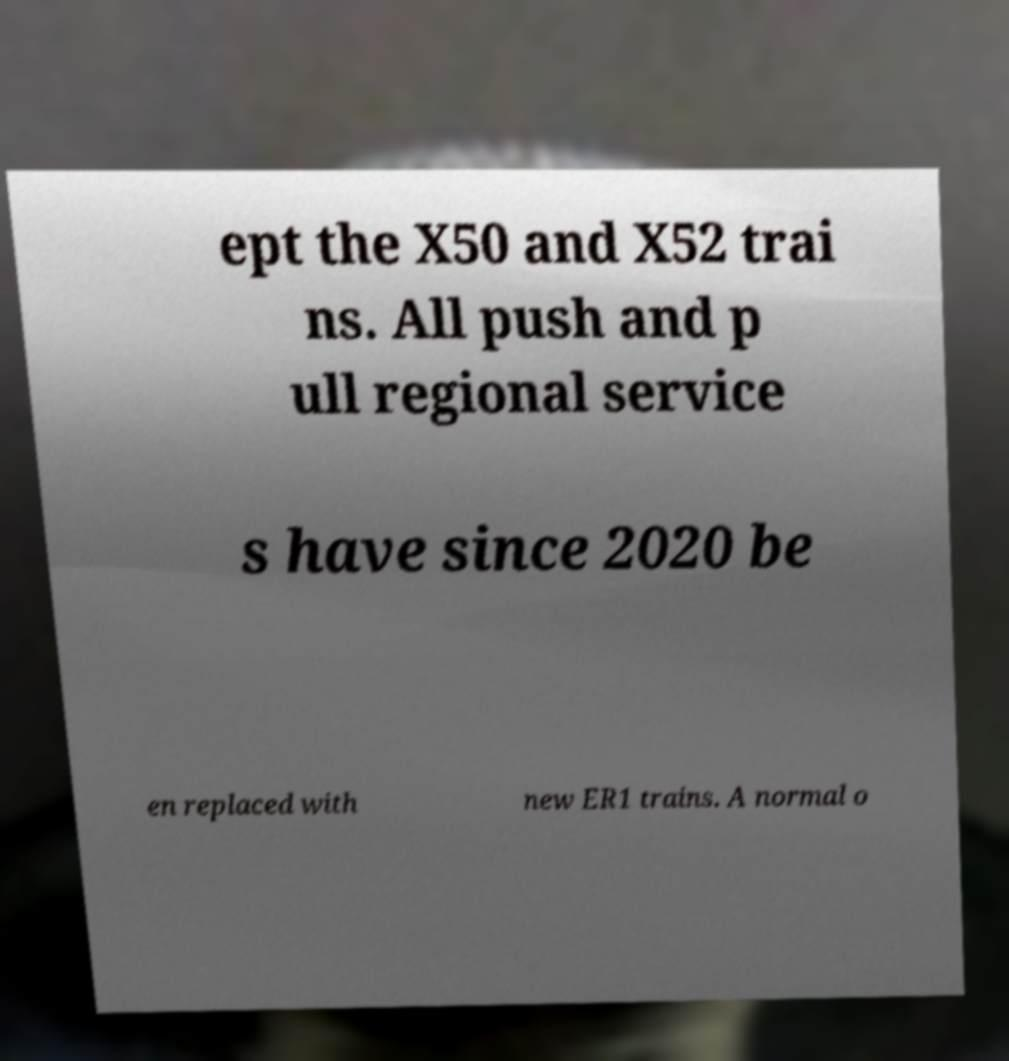Can you accurately transcribe the text from the provided image for me? ept the X50 and X52 trai ns. All push and p ull regional service s have since 2020 be en replaced with new ER1 trains. A normal o 